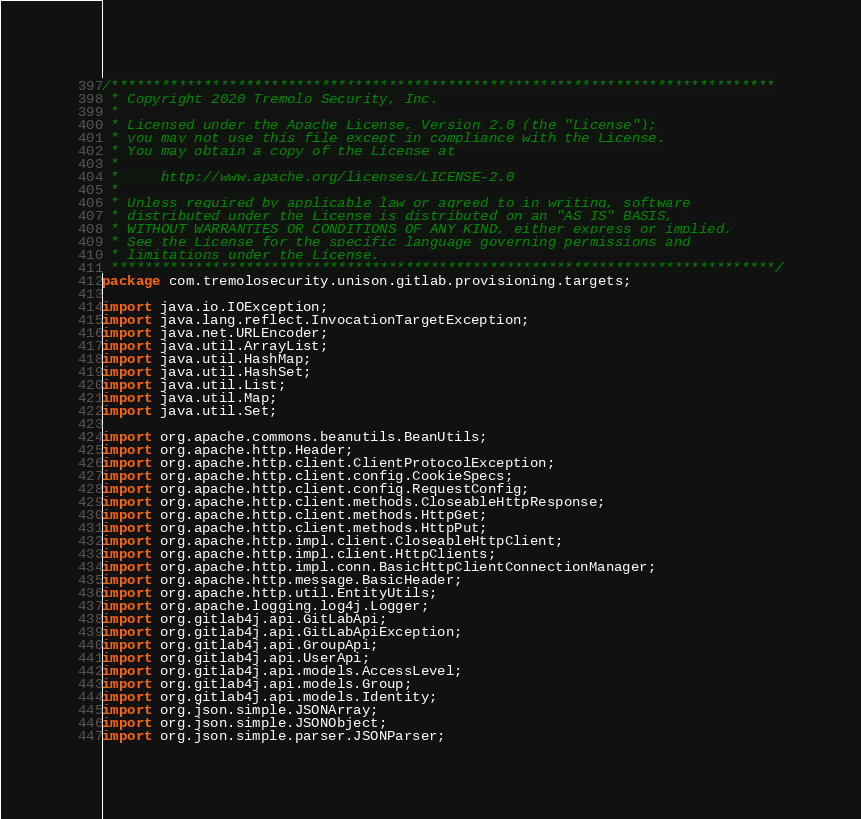Convert code to text. <code><loc_0><loc_0><loc_500><loc_500><_Java_>/*******************************************************************************
 * Copyright 2020 Tremolo Security, Inc.
 *
 * Licensed under the Apache License, Version 2.0 (the "License");
 * you may not use this file except in compliance with the License.
 * You may obtain a copy of the License at
 *
 *     http://www.apache.org/licenses/LICENSE-2.0
 *
 * Unless required by applicable law or agreed to in writing, software
 * distributed under the License is distributed on an "AS IS" BASIS,
 * WITHOUT WARRANTIES OR CONDITIONS OF ANY KIND, either express or implied.
 * See the License for the specific language governing permissions and
 * limitations under the License.
 *******************************************************************************/
package com.tremolosecurity.unison.gitlab.provisioning.targets;

import java.io.IOException;
import java.lang.reflect.InvocationTargetException;
import java.net.URLEncoder;
import java.util.ArrayList;
import java.util.HashMap;
import java.util.HashSet;
import java.util.List;
import java.util.Map;
import java.util.Set;

import org.apache.commons.beanutils.BeanUtils;
import org.apache.http.Header;
import org.apache.http.client.ClientProtocolException;
import org.apache.http.client.config.CookieSpecs;
import org.apache.http.client.config.RequestConfig;
import org.apache.http.client.methods.CloseableHttpResponse;
import org.apache.http.client.methods.HttpGet;
import org.apache.http.client.methods.HttpPut;
import org.apache.http.impl.client.CloseableHttpClient;
import org.apache.http.impl.client.HttpClients;
import org.apache.http.impl.conn.BasicHttpClientConnectionManager;
import org.apache.http.message.BasicHeader;
import org.apache.http.util.EntityUtils;
import org.apache.logging.log4j.Logger;
import org.gitlab4j.api.GitLabApi;
import org.gitlab4j.api.GitLabApiException;
import org.gitlab4j.api.GroupApi;
import org.gitlab4j.api.UserApi;
import org.gitlab4j.api.models.AccessLevel;
import org.gitlab4j.api.models.Group;
import org.gitlab4j.api.models.Identity;
import org.json.simple.JSONArray;
import org.json.simple.JSONObject;
import org.json.simple.parser.JSONParser;</code> 